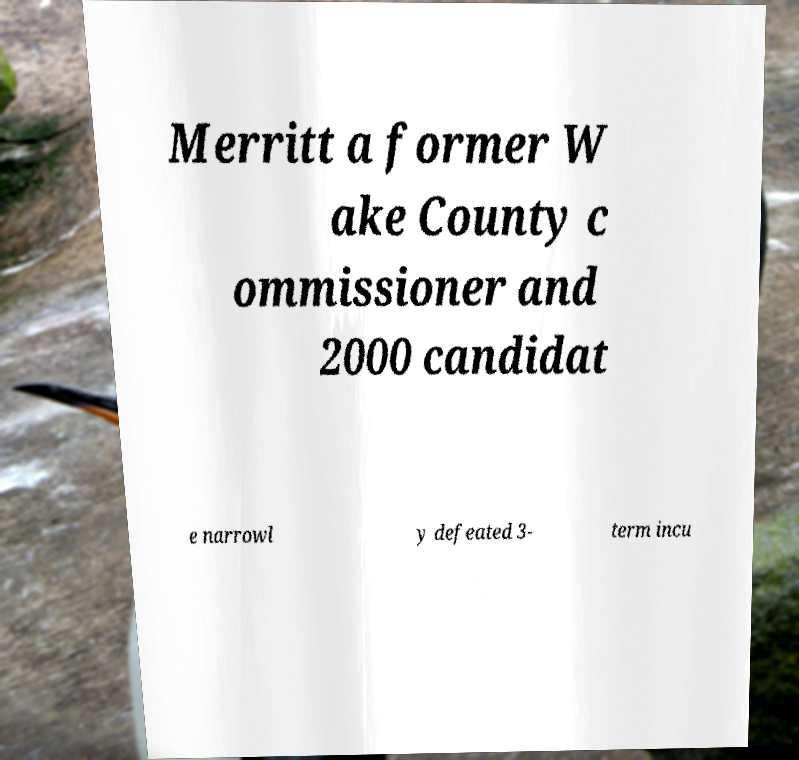Can you accurately transcribe the text from the provided image for me? Merritt a former W ake County c ommissioner and 2000 candidat e narrowl y defeated 3- term incu 